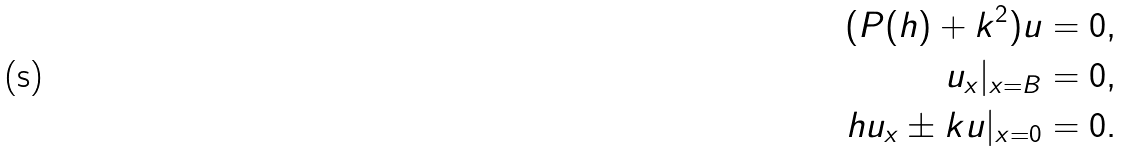Convert formula to latex. <formula><loc_0><loc_0><loc_500><loc_500>( P ( h ) + k ^ { 2 } ) u = 0 , \\ u _ { x } | _ { x = B } = 0 , \\ h u _ { x } \pm k u | _ { x = 0 } = 0 .</formula> 